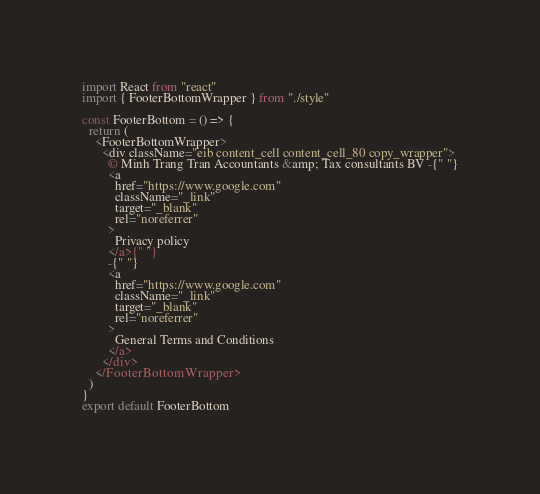Convert code to text. <code><loc_0><loc_0><loc_500><loc_500><_JavaScript_>import React from "react"
import { FooterBottomWrapper } from "./style"

const FooterBottom = () => {
  return (
    <FooterBottomWrapper>
      <div className="eib content_cell content_cell_80 copy_wrapper">
        © Minh Trang Tran Accountants &amp; Tax consultants BV -{" "}
        <a
          href="https://www.google.com"
          className="_link"
          target="_blank"
          rel="noreferrer"
        >
          Privacy policy
        </a>{" "}
        -{" "}
        <a
          href="https://www.google.com"
          className="_link"
          target="_blank"
          rel="noreferrer"
        >
          General Terms and Conditions
        </a>
      </div>
    </FooterBottomWrapper>
  )
}
export default FooterBottom
</code> 